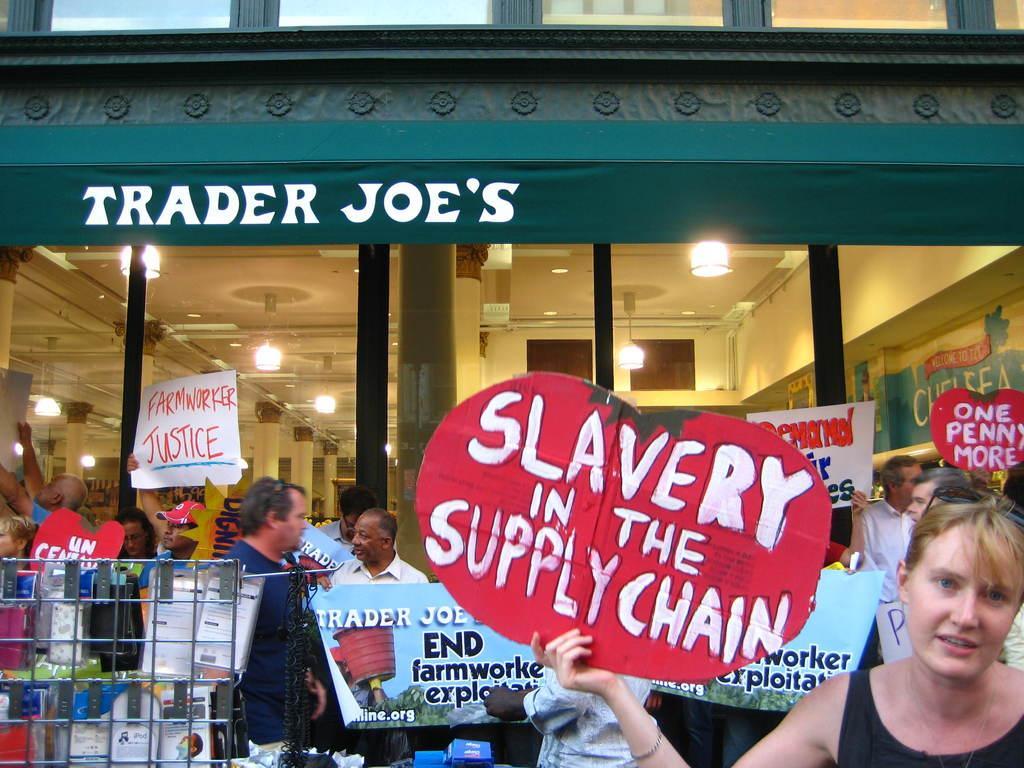Please provide a concise description of this image. In this picture we can see some people are standing, some of them are holding boards, in the background there is a building, at the left bottom we can see some books, there is a glass in the middle, from the glass we can see pillars and lights, a person in the middle is holding a banner, we can see some text on these boards. 